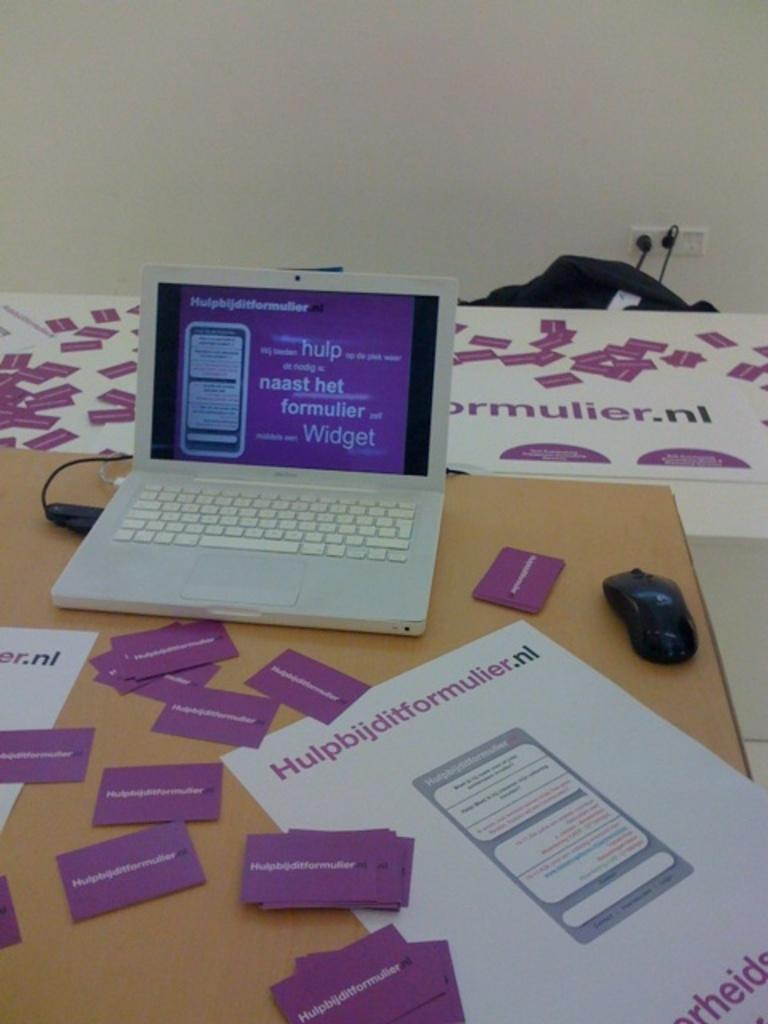<image>
Relay a brief, clear account of the picture shown. The young woman is trying to learn German with the brand "Hulpbijditformuler.nl" 